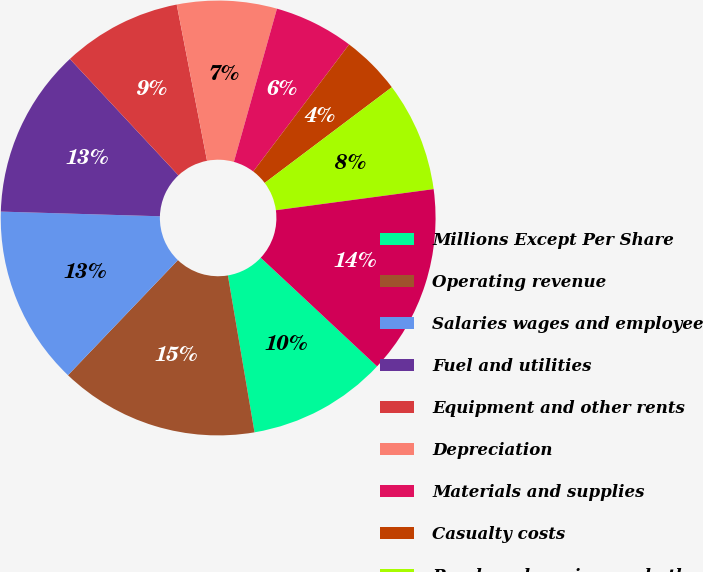Convert chart. <chart><loc_0><loc_0><loc_500><loc_500><pie_chart><fcel>Millions Except Per Share<fcel>Operating revenue<fcel>Salaries wages and employee<fcel>Fuel and utilities<fcel>Equipment and other rents<fcel>Depreciation<fcel>Materials and supplies<fcel>Casualty costs<fcel>Purchased services and other<fcel>Total operating expenses<nl><fcel>10.37%<fcel>14.81%<fcel>13.33%<fcel>12.59%<fcel>8.89%<fcel>7.41%<fcel>5.93%<fcel>4.44%<fcel>8.15%<fcel>14.07%<nl></chart> 